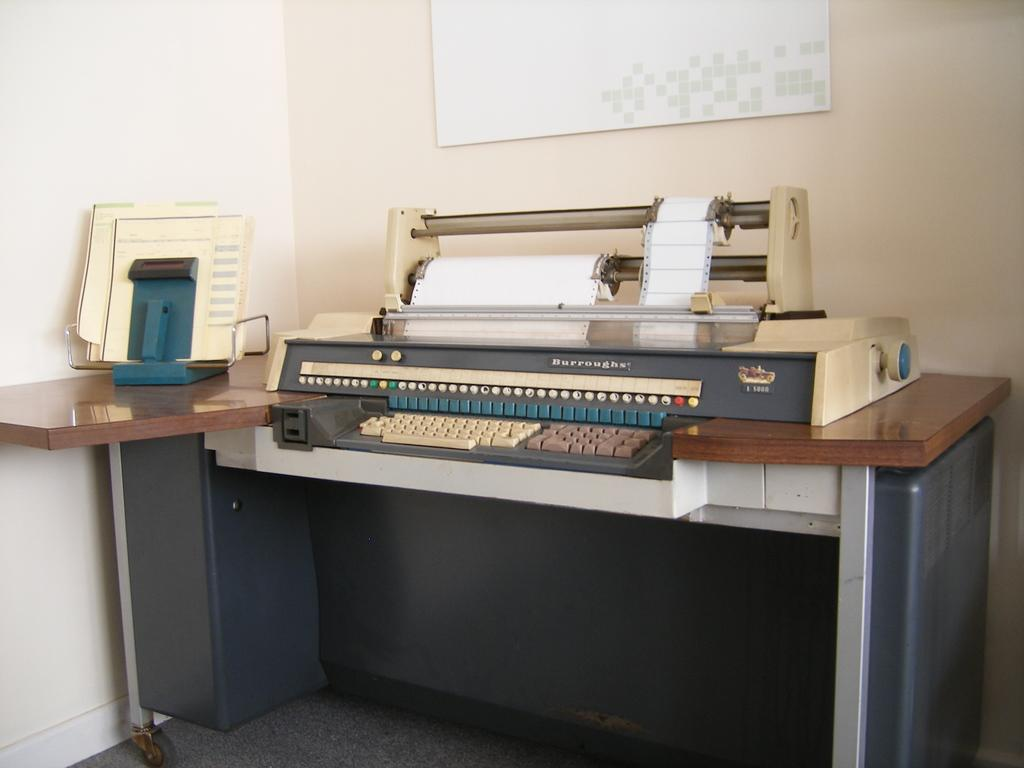What is the main object in the image? There is a typewriter in the image. Where is the typewriter located? The typewriter is placed on a table. Can you describe the position of the table in the image? The table is at the center of the image. What color is the vest worn by the achiever in the image? There is no achiever or vest present in the image; it only features a typewriter on a table. 